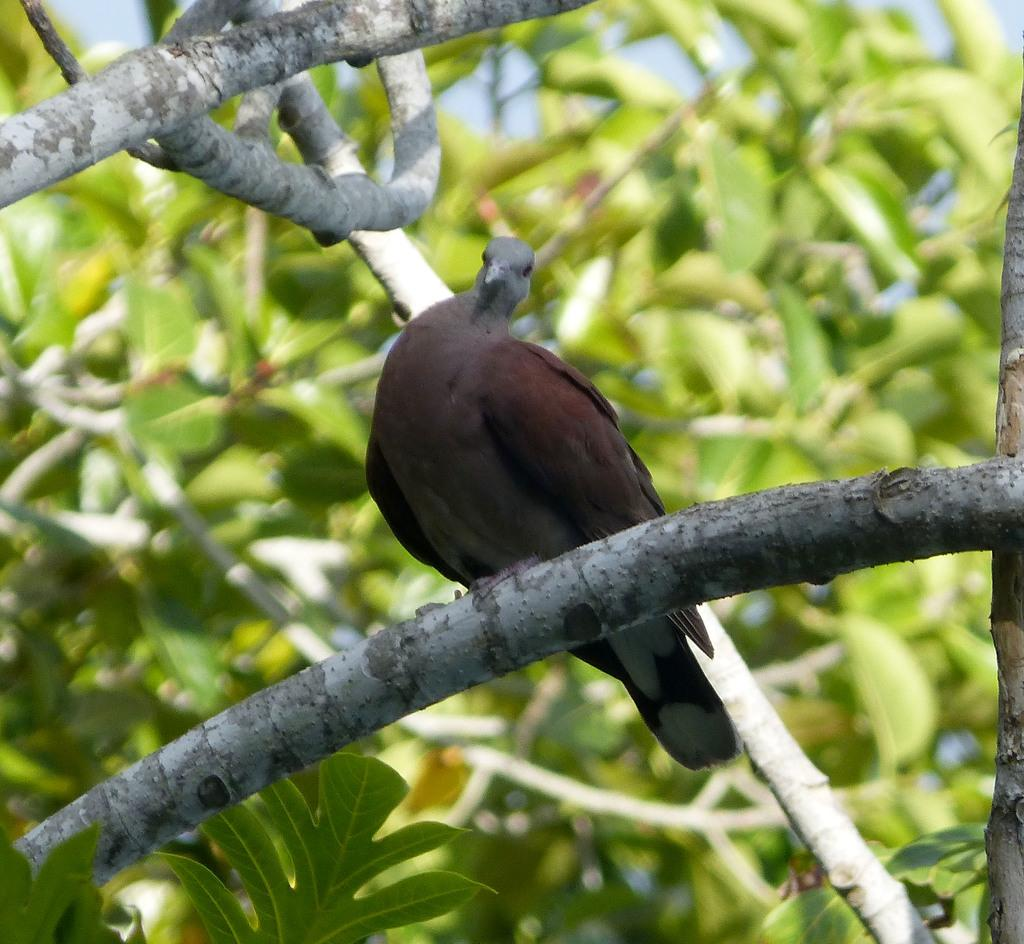What type of animal can be seen in the image? There is a bird in the image. Where is the bird located? The bird is sitting on a branch. What can be seen in the background of the image? There are plants visible in the background of the image. What type of cloth is draped over the bird in the image? There is no cloth draped over the bird in the image; the bird is sitting on a branch with no cloth present. 